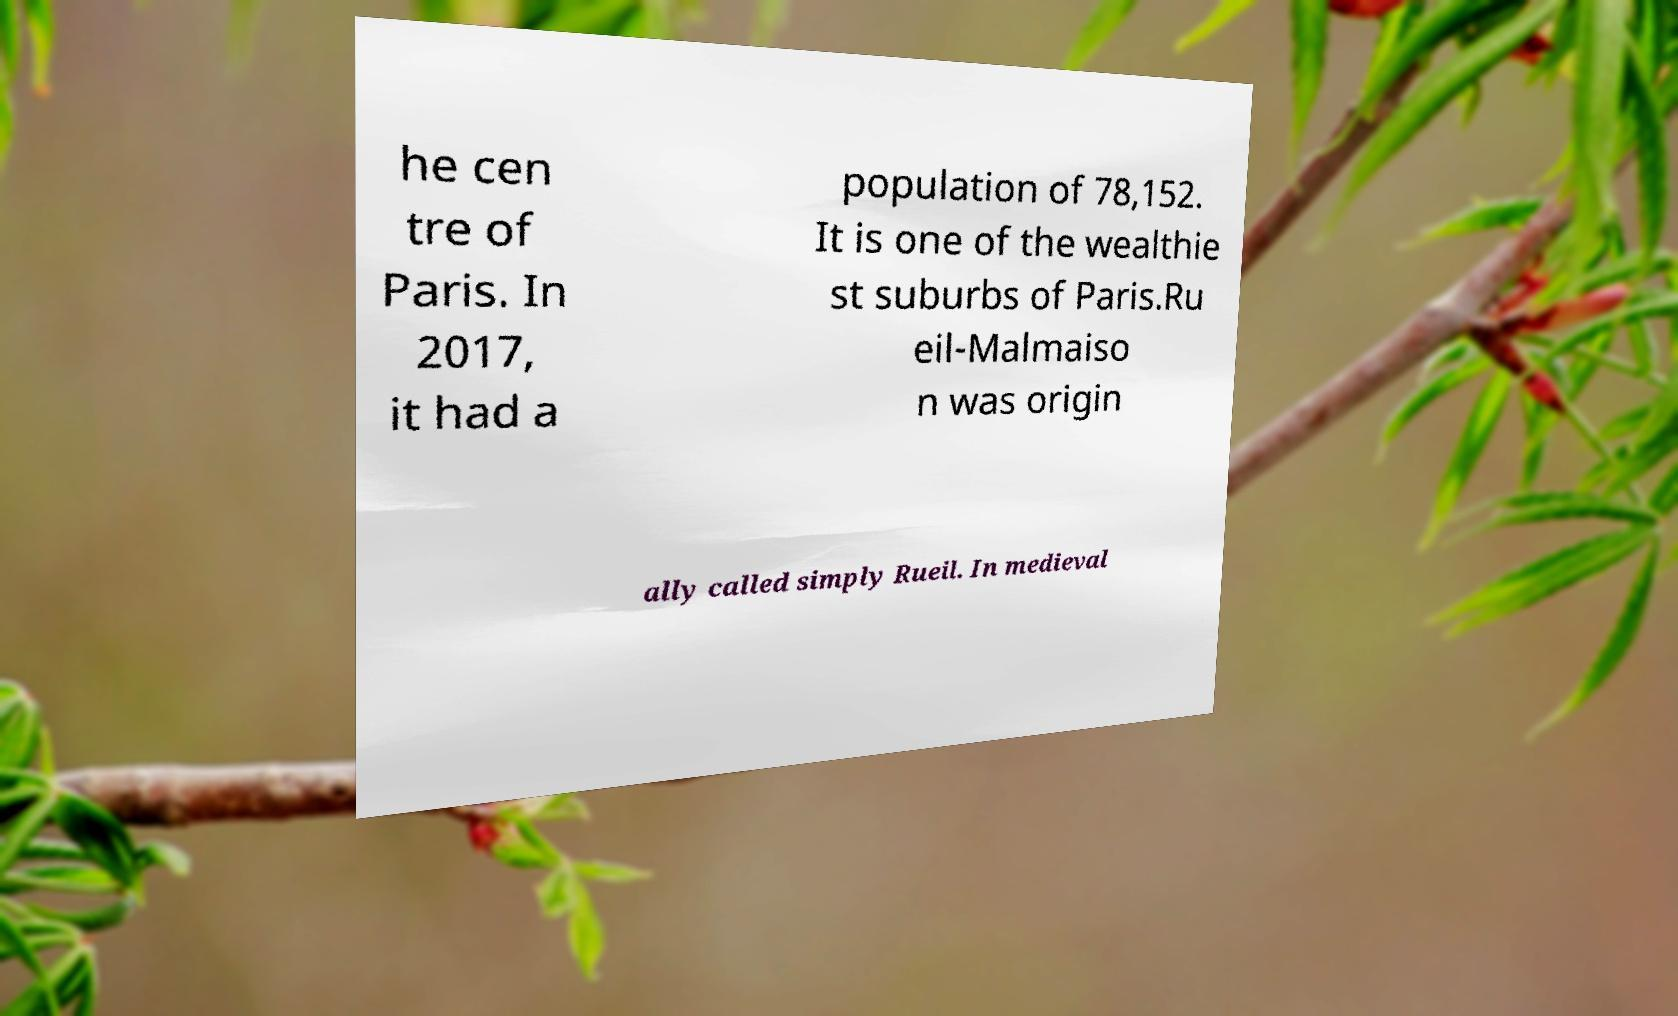For documentation purposes, I need the text within this image transcribed. Could you provide that? he cen tre of Paris. In 2017, it had a population of 78,152. It is one of the wealthie st suburbs of Paris.Ru eil-Malmaiso n was origin ally called simply Rueil. In medieval 